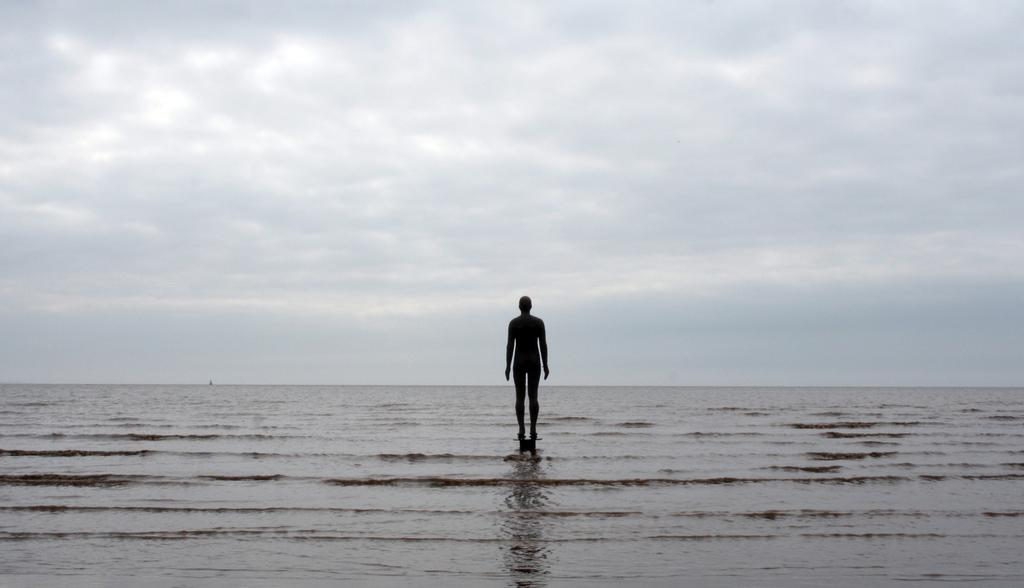What is the main subject of the image? There is an object that resembles a statue of a person in the image. What can be seen in the background of the image? The sky is visible in the image. What natural feature is present in the image? The ocean is present in the image. What type of sponge can be seen floating in the ocean in the image? There is no sponge present in the image; it only features a statue-like object and the ocean. 